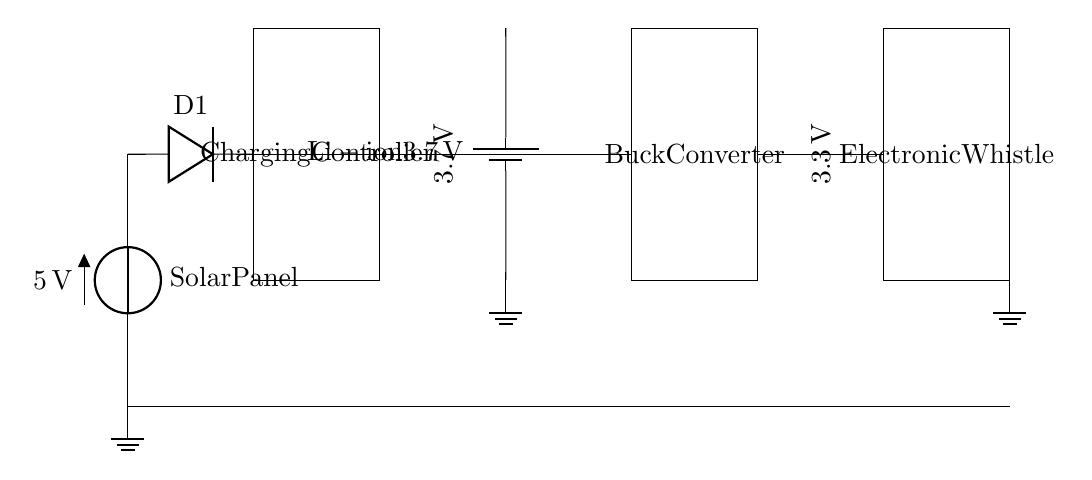What is the voltage of the solar panel? The solar panel generates a voltage of 5 volts, as indicated in the circuit diagram next to the solar panel label.
Answer: 5 volts What type of battery is used in the circuit? The circuit includes a lithium-ion battery, as specified in the label next to the battery symbol in the diagram.
Answer: Lithium-ion What is the purpose of the diode in the circuit? The diode prevents reverse current, ensuring that the current flows only in one direction from the solar panel to the charging controller, protecting the components downstream.
Answer: Prevents reverse current What is the output voltage of the buck converter? The output voltage of the buck converter is 3.3 volts, as shown in the label next to the buck converter in the circuit diagram.
Answer: 3.3 volts What does the charging controller do in the circuit? The charging controller regulates the voltage and current coming from the solar panel to safely charge the battery and ensure efficient operation without overcharging.
Answer: Regulates charging How are the components connected in the circuit? The components are connected in series from the solar panel providing voltage to the charging controller, which charges the battery, while the buck converter steps down the voltage to power the electronic whistle.
Answer: Series connection 